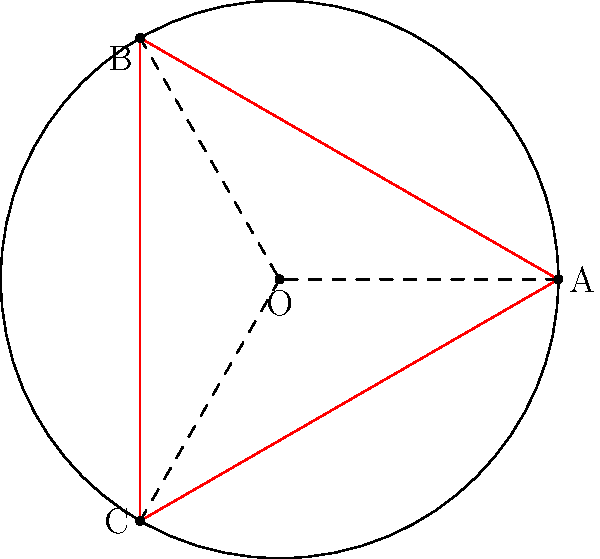As a junior officer tasked with optimizing patrol routes, you need to determine the most efficient path around a circular base perimeter. The base has a radius of 300 meters. Is it more efficient for a patrol to walk along the perimeter (route ABC) or to use the triangular path (route AOB + BOC + COA)? Calculate the difference in distance between these two routes. Let's approach this step-by-step:

1) First, let's calculate the circumference of the circle (route ABC):
   $$C = 2\pi r = 2\pi \cdot 300 = 600\pi \approx 1884.96 \text{ meters}$$

2) Now, let's calculate the length of one side of the equilateral triangle (s):
   $$s = 2r \sin(\frac{\pi}{3}) = 2 \cdot 300 \cdot \sin(60°) = 600 \cdot \frac{\sqrt{3}}{2} = 300\sqrt{3} \approx 519.62 \text{ meters}$$

3) The perimeter of the triangle is:
   $$3s = 3 \cdot 300\sqrt{3} = 900\sqrt{3} \approx 1558.85 \text{ meters}$$

4) To calculate the difference:
   $$\text{Difference} = 600\pi - 900\sqrt{3} \approx 326.11 \text{ meters}$$

Therefore, the triangular route (AOB + BOC + COA) is shorter by approximately 326.11 meters.
Answer: The triangular route is more efficient, saving approximately 326.11 meters. 